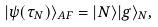<formula> <loc_0><loc_0><loc_500><loc_500>| \psi ( \tau _ { N } ) \rangle _ { A F } = | N \rangle | g \rangle _ { N } ,</formula> 